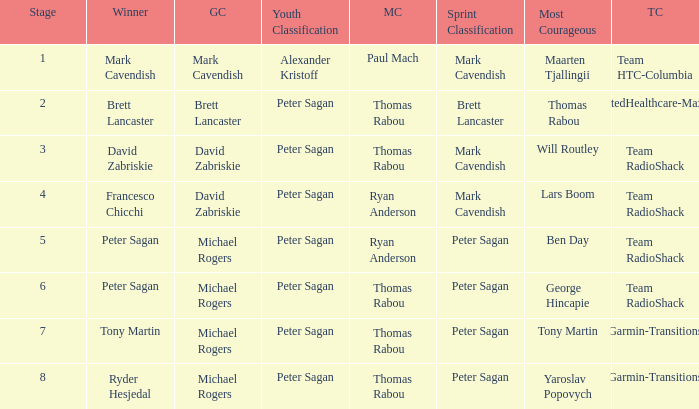When Mark Cavendish wins sprint classification and Maarten Tjallingii wins most courageous, who wins youth classification? Alexander Kristoff. 